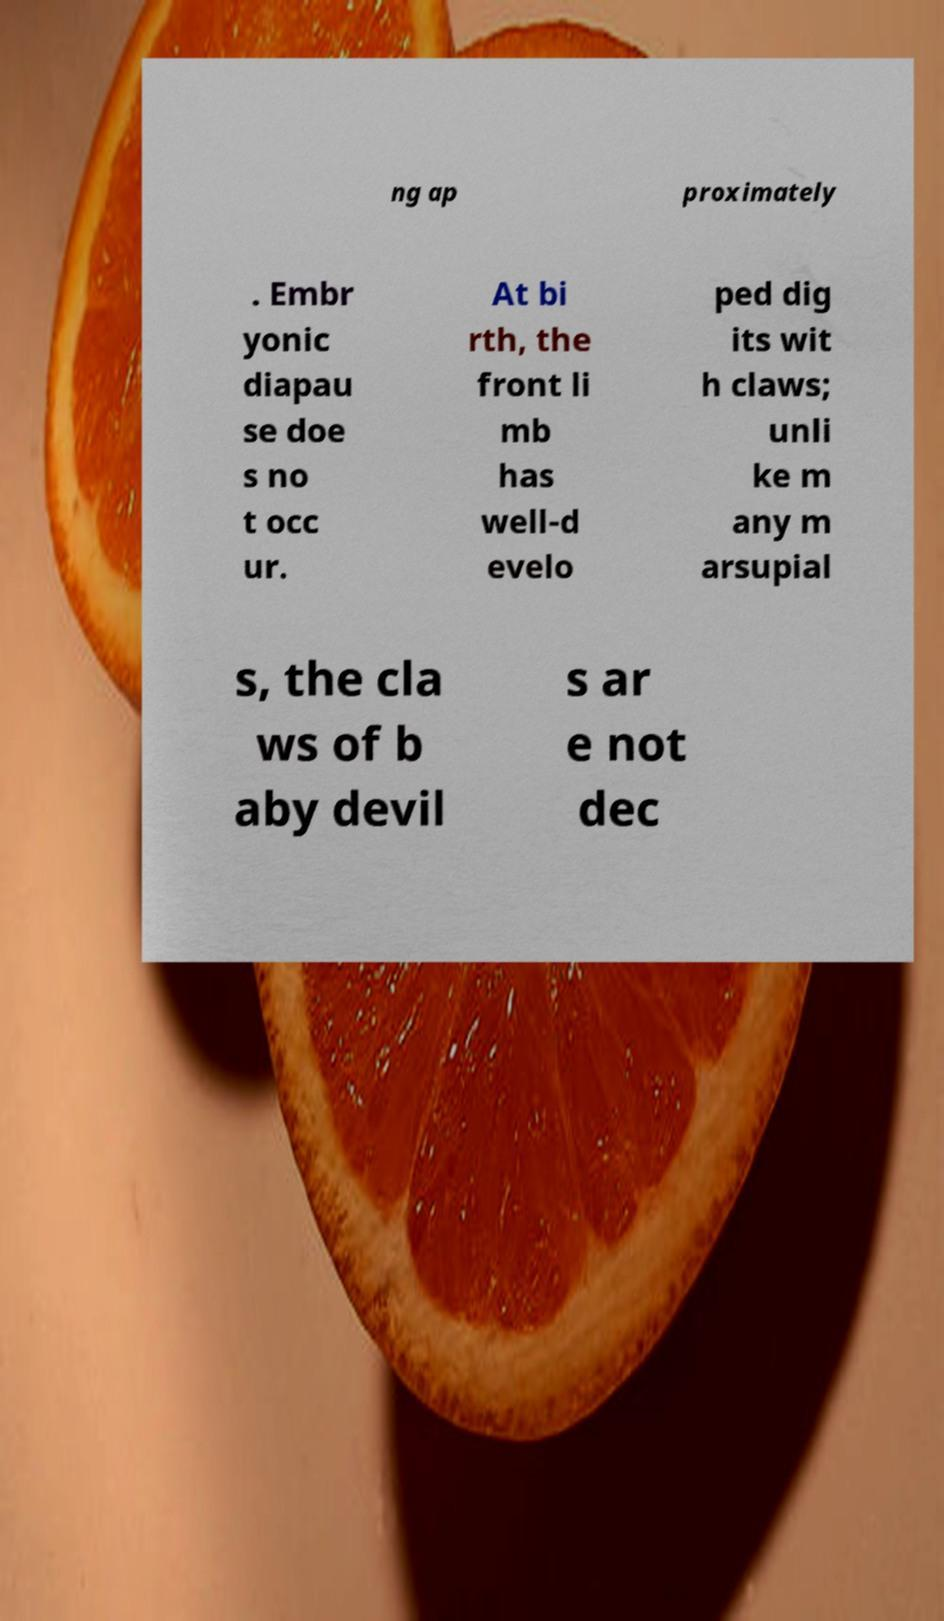There's text embedded in this image that I need extracted. Can you transcribe it verbatim? ng ap proximately . Embr yonic diapau se doe s no t occ ur. At bi rth, the front li mb has well-d evelo ped dig its wit h claws; unli ke m any m arsupial s, the cla ws of b aby devil s ar e not dec 